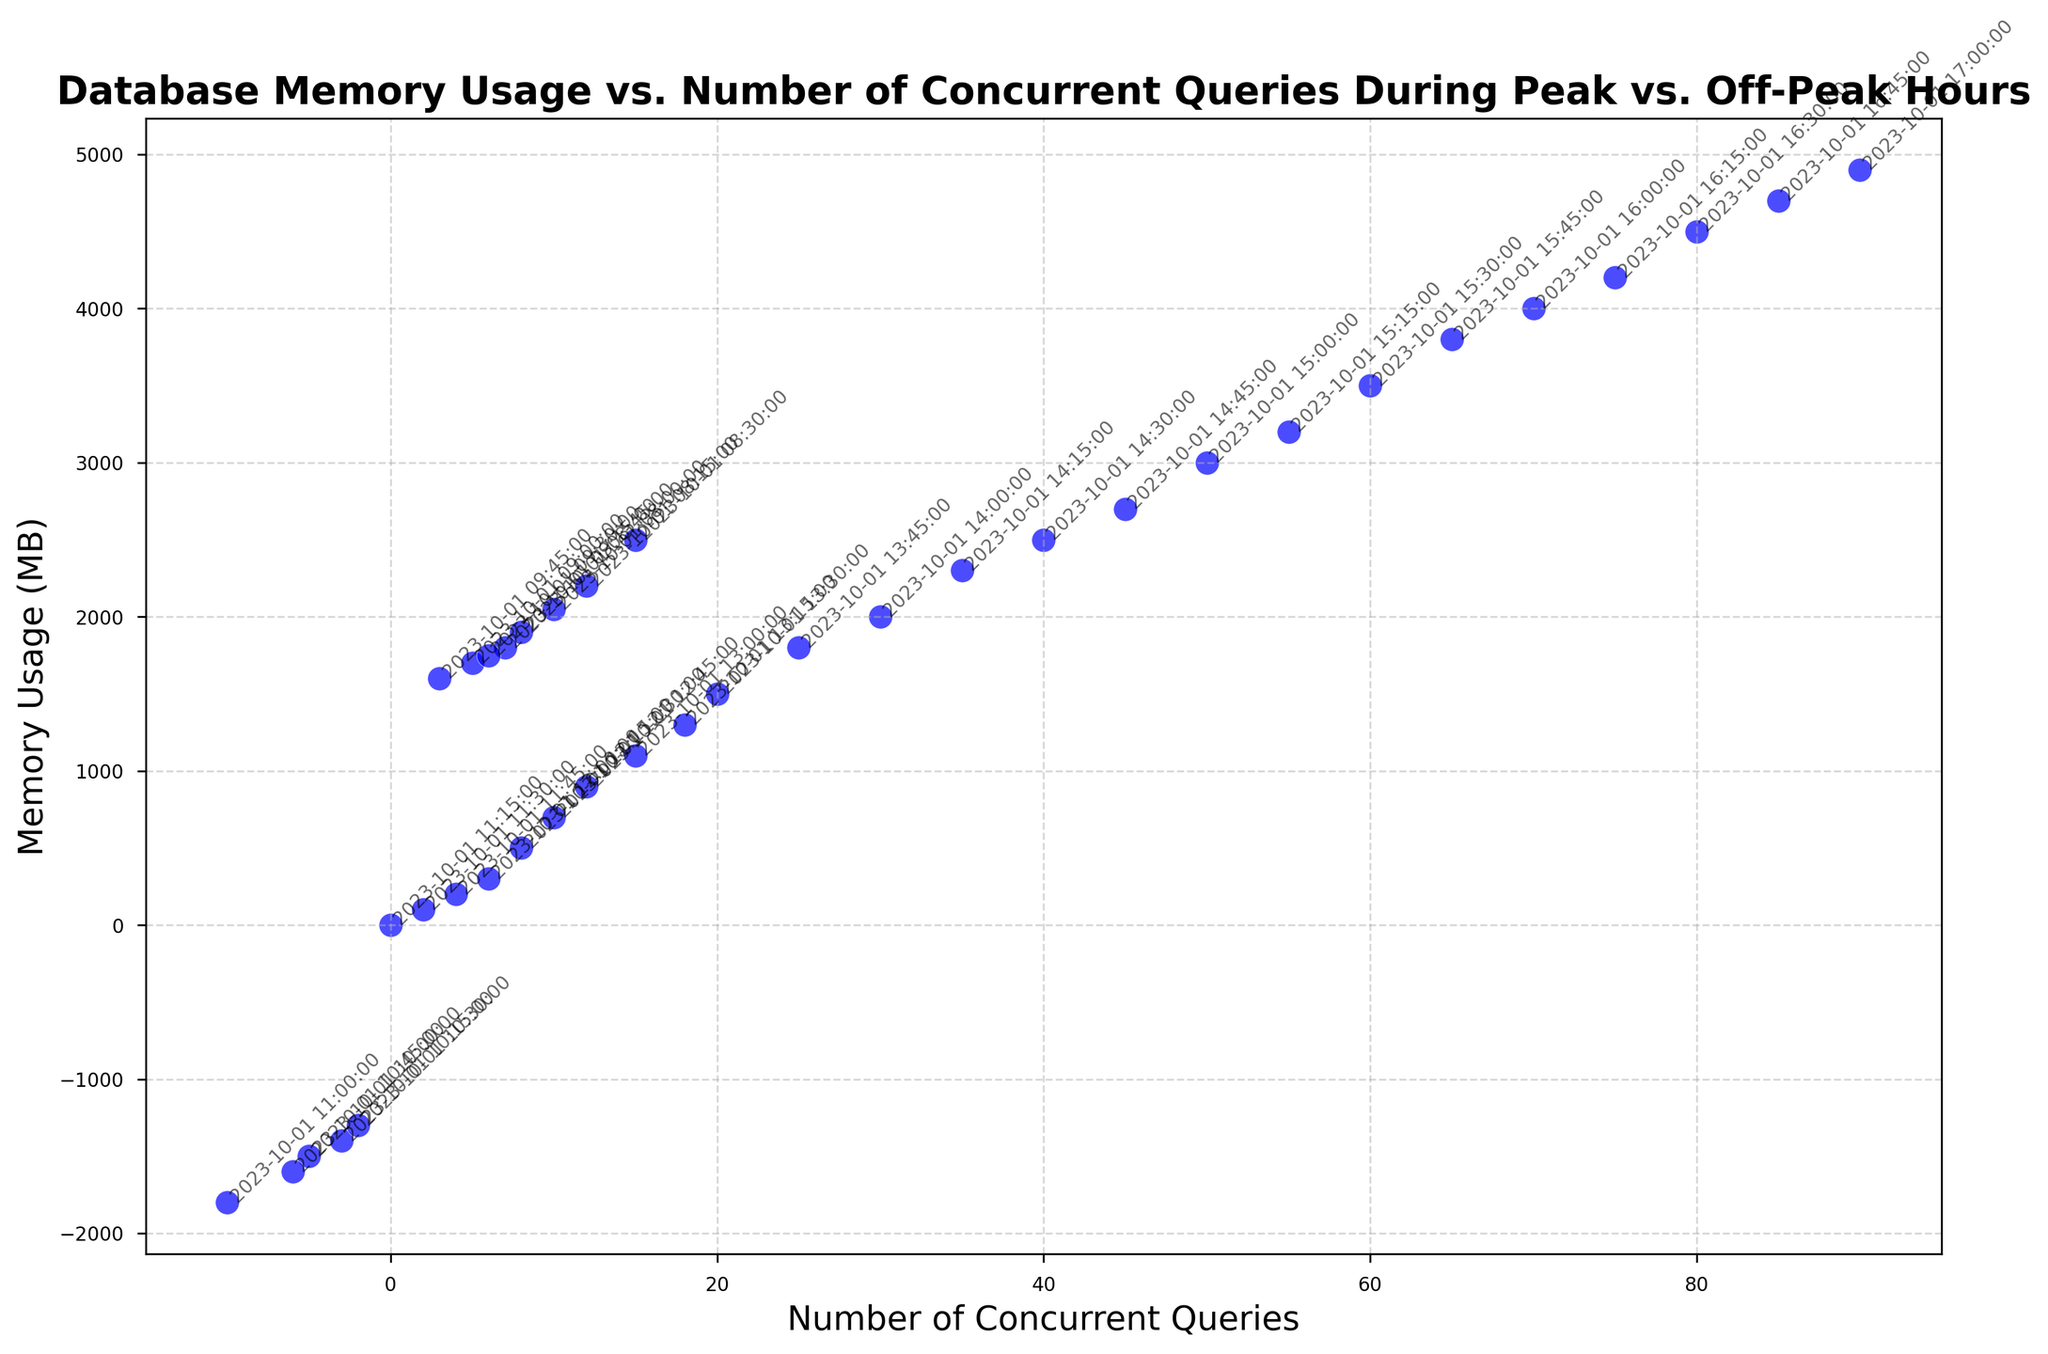What is the peak value of memory usage, and at what number of concurrent queries does it occur? The peak memory usage can be found where the highest y-coordinate in the scatter plot is. According to the plot, the highest memory usage is 4900 MB, and it occurs when the number of concurrent queries is 90, represented by a point at (90, 4900)
Answer: 4900 MB at 90 concurrent queries During which hour block does the number of concurrent queries go negative, and what is the corresponding memory usage range? Look for time annotations in the scatter plot with negative concurrent queries on the x-axis. Negative values appear between 10:00 AM and 11:00 AM. The corresponding memory usage ranges from -1800 MB to -1300 MB
Answer: 10:00 AM to 11:00 AM, memory usage from -1800 MB to -1300 MB Compare the memory usage at 10 concurrent queries before and after the drop at 10:00 AM. Locate the data points where the number of concurrent queries is 10 on either side of the 10:00 AM drop. Before the drop, at 10 queries, memory usage is 2048 MB, and afterward, the highest memory usage at 10 queries is 700 MB
Answer: 2048 MB before the drop, 700 MB after the drop What is the trend of memory usage as the number of concurrent queries increases from 0 to 90? Starting from 0 to 90 concurrent queries, visually follow the scatter points from left to right while noting their y-coordinates. Memory usage starts at 0 MB and generally increases as the number of concurrent queries increases, peaking at 4900 MB
Answer: Increasing trend Find the average memory usage between 12:00 PM and 1:00 PM and compare it to the average from 1:00 PM to 2:00 PM. Identify the data points within these two time blocks and calculate the average of their memory usage. From 12:00 PM to 1:00 PM: (500 + 700 + 900 + 1100)/4 = 800. From 1:00 PM to 2:00 PM: (1300 + 1500 + 1800 + 2000)/4 = 1650. Hence, the average from 1:00 PM to 2:00 PM is higher
Answer: 800 MB for 12:00 PM - 1:00 PM, 1650 MB for 1:00 PM - 2:00 PM Based on the data, during which time interval is memory usage the most stable, and what is the range of usage in this interval? Examine intervals where the points on the scatter plot are closest in terms of memory usage. The 8:00 AM to 9:30 AM interval appears the most stable as the y-coordinates (memory usage) don't vary widely: from 2048 MB to 1750 MB
Answer: 8:00 AM to 9:30 AM, range from 2048 MB to 1750 MB 